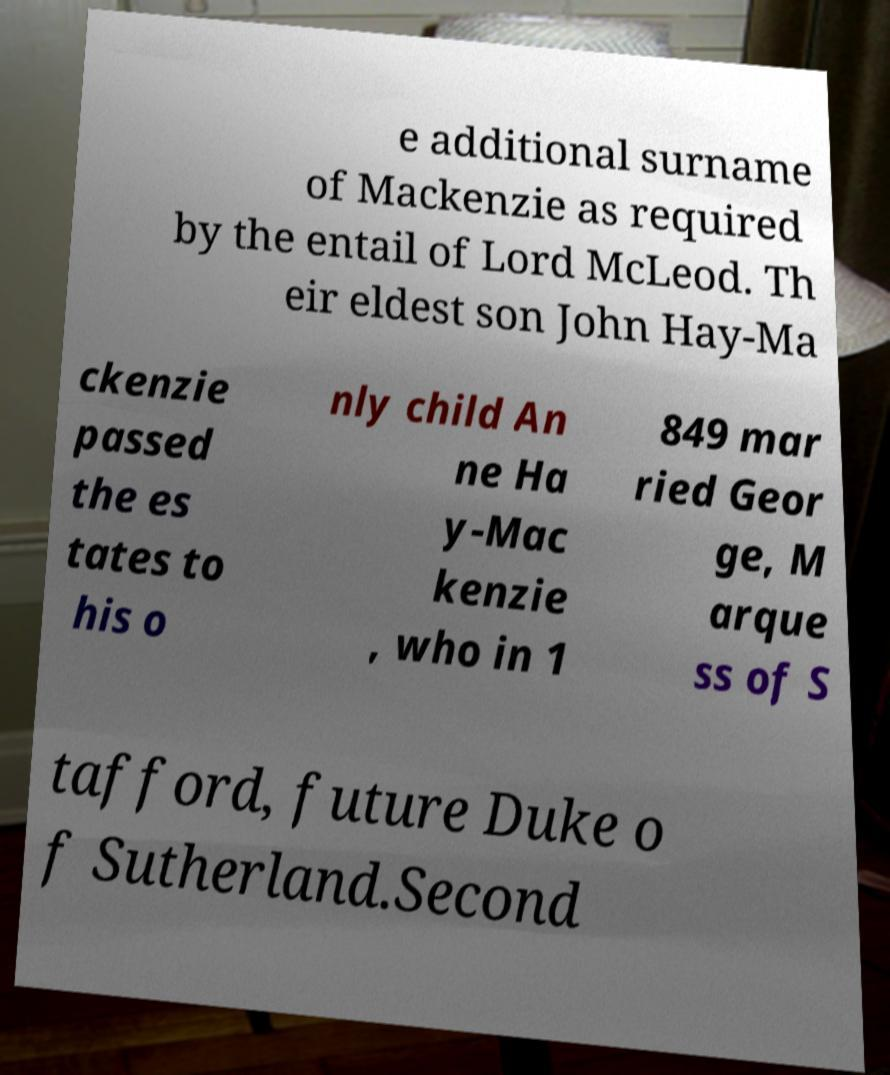There's text embedded in this image that I need extracted. Can you transcribe it verbatim? e additional surname of Mackenzie as required by the entail of Lord McLeod. Th eir eldest son John Hay-Ma ckenzie passed the es tates to his o nly child An ne Ha y-Mac kenzie , who in 1 849 mar ried Geor ge, M arque ss of S tafford, future Duke o f Sutherland.Second 